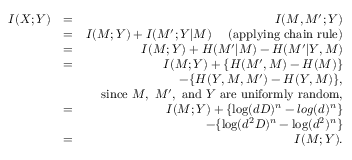Convert formula to latex. <formula><loc_0><loc_0><loc_500><loc_500>\begin{array} { r l r } { I ( X ; Y ) } & { = } & { I ( M , M ^ { \prime } ; Y ) } \\ & { = } & { I ( M ; Y ) + I ( M ^ { \prime } ; Y | M ) ( a p p l y i n g c h a i n r u l e ) } \\ & { = } & { I ( M ; Y ) + H ( M ^ { \prime } | M ) - H ( M ^ { \prime } | Y , M ) } \\ & { = } & { I ( M ; Y ) + \{ H ( M ^ { \prime } , M ) - H ( M ) \} } \\ & { - \{ H ( Y , M , M ^ { \prime } ) - H ( Y , M ) \} , } \\ & { \sin c e M , M ^ { \prime } , a n d Y a r e u n i f o r m l y r a n d o m , } \\ & { = } & { I ( M ; Y ) + \{ \log ( d D ) ^ { n } - \log ( d ) ^ { n } \} } \\ & { - \{ \log ( d ^ { 2 } D ) ^ { n } - \log ( d ^ { 2 } ) ^ { n } \} } \\ & { = } & { I ( M ; Y ) . } \end{array}</formula> 